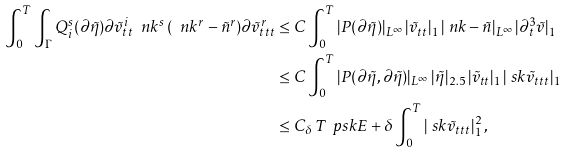<formula> <loc_0><loc_0><loc_500><loc_500>\int _ { 0 } ^ { T } \int _ { \Gamma } Q ^ { s } _ { i } ( \partial \tilde { \eta } ) \partial \tilde { v } ^ { i } _ { t t } \ n k ^ { s } \, ( \ n k ^ { r } - \tilde { n } ^ { r } ) \partial \tilde { v } ^ { r } _ { t t t } & \leq C \int _ { 0 } ^ { T } | P ( \partial \tilde { \eta } ) | _ { L ^ { \infty } } \, | \tilde { v } _ { t t } | _ { 1 } \, | \ n k - \tilde { n } | _ { L ^ { \infty } } \, | \partial _ { t } ^ { 3 } \tilde { v } | _ { 1 } \\ & \leq C \int _ { 0 } ^ { T } | P ( \partial \tilde { \eta } , \partial \tilde { \eta } ) | _ { L ^ { \infty } } \, | \tilde { \eta } | _ { 2 . 5 } \, | \tilde { v } _ { t t } | _ { 1 } \, | \ s k \tilde { v } _ { t t t } | _ { 1 } \\ & \leq C _ { \delta } \, T \, \ p s k E + \delta \int _ { 0 } ^ { T } | \ s k \tilde { v } _ { t t t } | _ { 1 } ^ { 2 } \, ,</formula> 